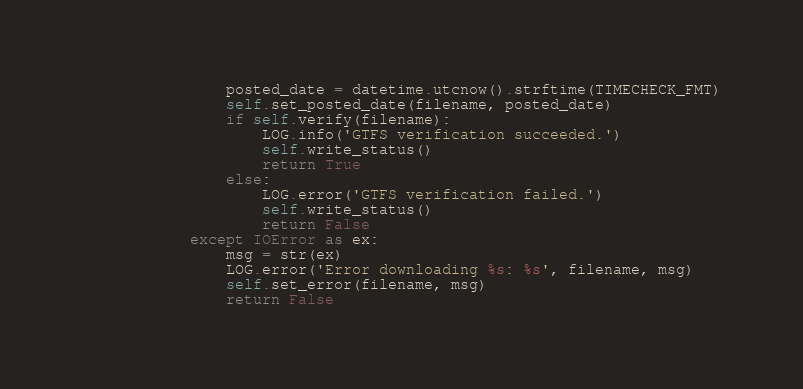Convert code to text. <code><loc_0><loc_0><loc_500><loc_500><_Python_>                posted_date = datetime.utcnow().strftime(TIMECHECK_FMT)
                self.set_posted_date(filename, posted_date)
                if self.verify(filename):
                    LOG.info('GTFS verification succeeded.')
                    self.write_status()
                    return True
                else:
                    LOG.error('GTFS verification failed.')
                    self.write_status()
                    return False
            except IOError as ex:
                msg = str(ex)
                LOG.error('Error downloading %s: %s', filename, msg)
                self.set_error(filename, msg)
                return False
</code> 